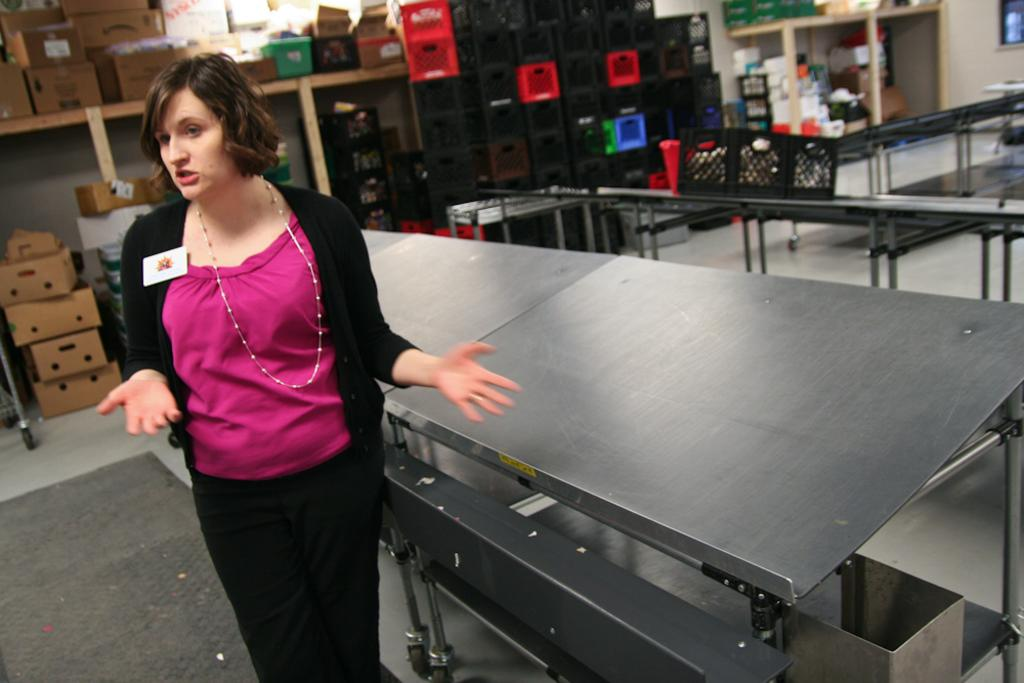What types of objects are present in the image? There are boxes and containers in the image. Who or what else can be seen in the image? There is a person in the image. How is the person dressed in the image? The person is wearing clothes. What is the person standing near in the image? The person is standing in front of tables. What type of sound can be heard coming from the boxes in the image? There is no sound coming from the boxes in the image, as they are inanimate objects. 